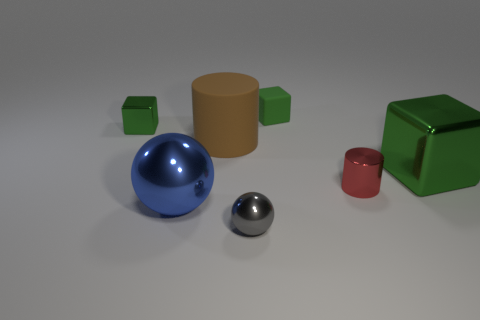How many green cubes must be subtracted to get 1 green cubes? 2 Subtract 1 cubes. How many cubes are left? 2 Add 3 large metal spheres. How many objects exist? 10 Subtract all cylinders. How many objects are left? 5 Add 3 tiny gray balls. How many tiny gray balls exist? 4 Subtract 0 purple spheres. How many objects are left? 7 Subtract all cubes. Subtract all big green things. How many objects are left? 3 Add 6 large objects. How many large objects are left? 9 